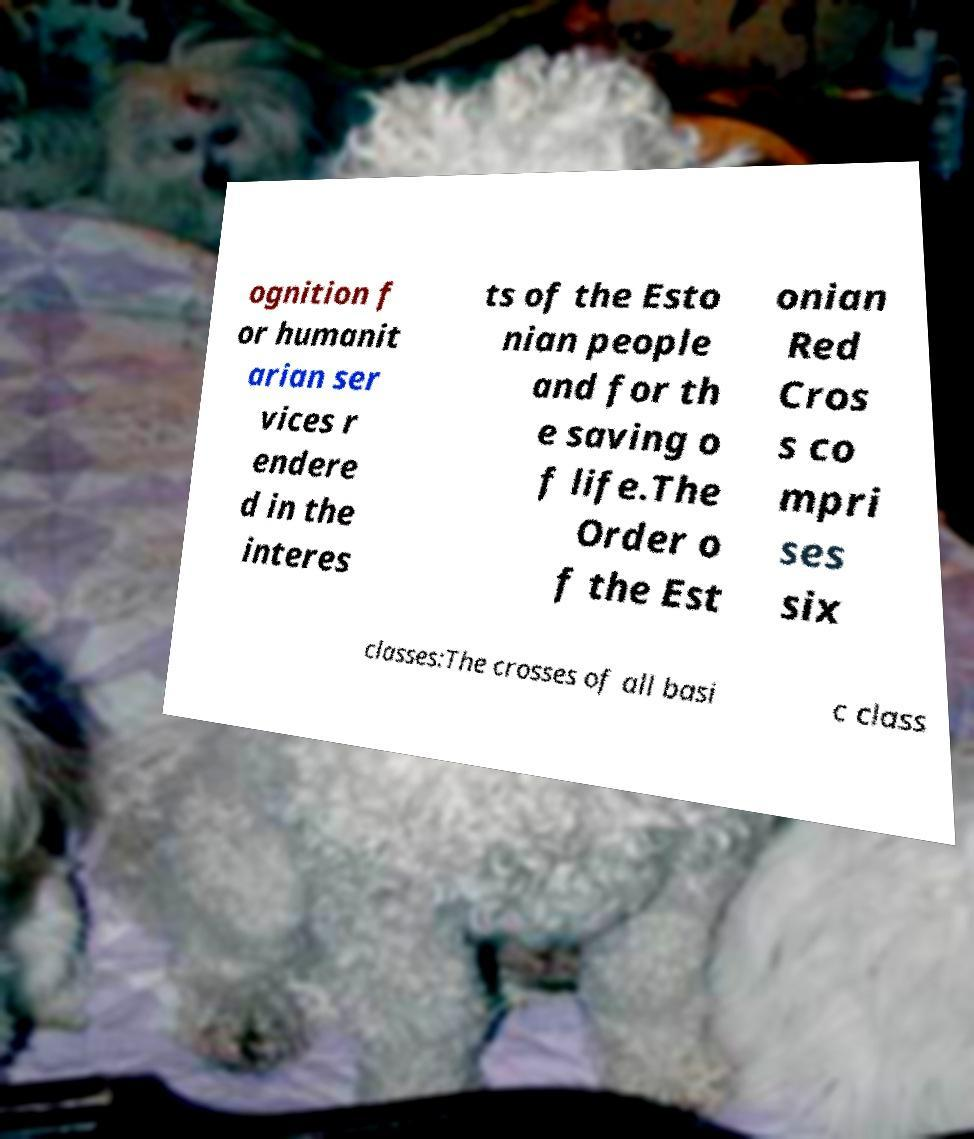Please identify and transcribe the text found in this image. ognition f or humanit arian ser vices r endere d in the interes ts of the Esto nian people and for th e saving o f life.The Order o f the Est onian Red Cros s co mpri ses six classes:The crosses of all basi c class 